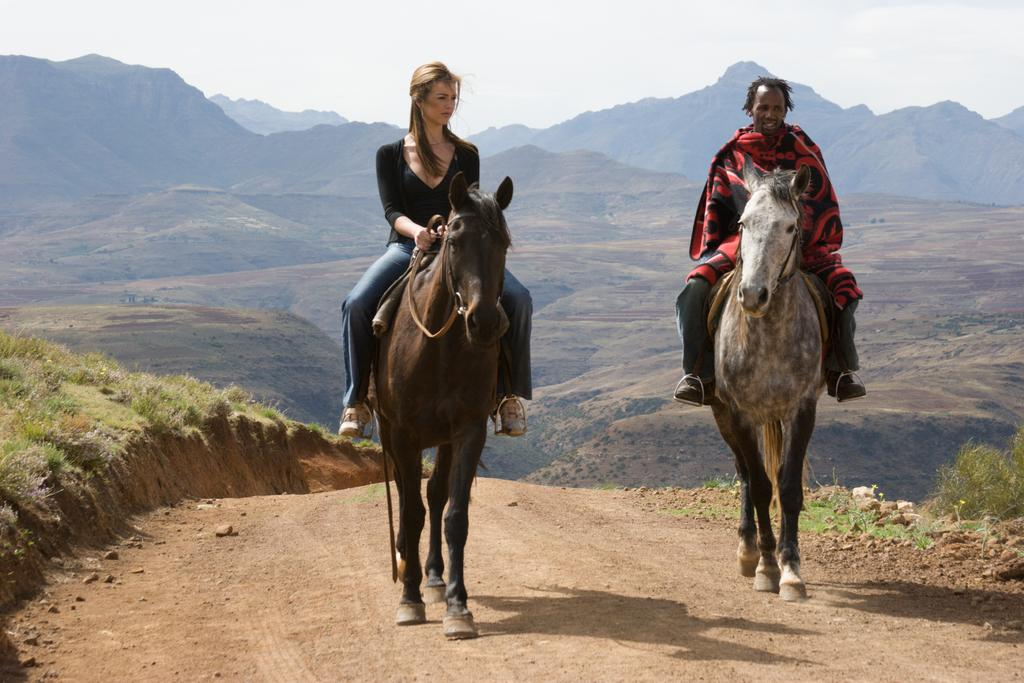How many people are in the image? There are two persons in the image. What are the persons doing in the image? The persons are sitting on horses. Where are the horses located in the image? The horses are at the center of the image. What can be seen in the background of the image? There are hills in the background of the image. What is visible at the top of the image? The sky is visible at the top of the image. What type of building can be seen in the memory of the person on the left horse? There is no building present in the image, nor is there any indication of a person's memory. 